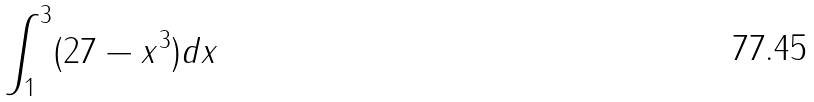<formula> <loc_0><loc_0><loc_500><loc_500>\int _ { 1 } ^ { 3 } ( 2 7 - x ^ { 3 } ) d x</formula> 